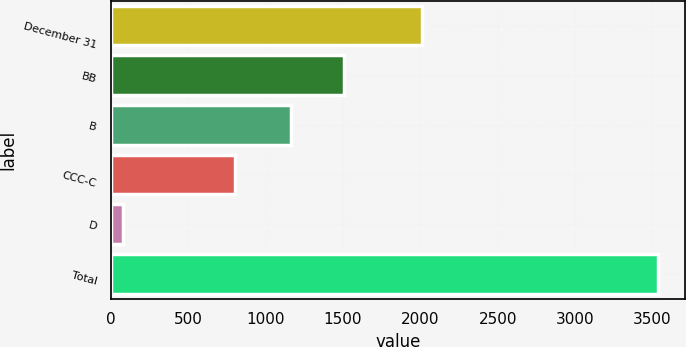Convert chart. <chart><loc_0><loc_0><loc_500><loc_500><bar_chart><fcel>December 31<fcel>BB<fcel>B<fcel>CCC-C<fcel>D<fcel>Total<nl><fcel>2010<fcel>1508.6<fcel>1163<fcel>801<fcel>78<fcel>3534<nl></chart> 